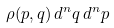<formula> <loc_0><loc_0><loc_500><loc_500>\rho ( p , q ) \, d ^ { n } q \, d ^ { n } p</formula> 